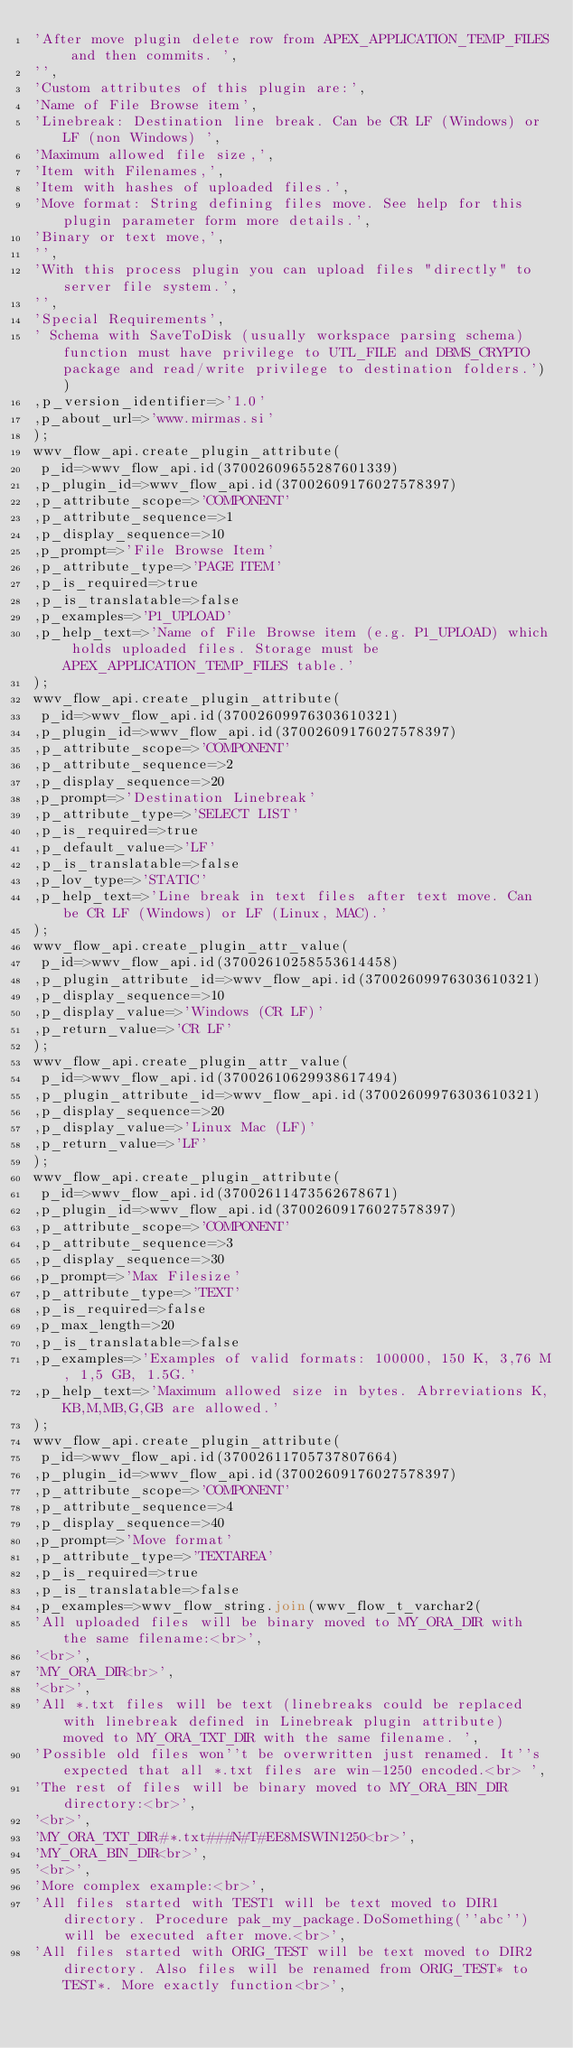Convert code to text. <code><loc_0><loc_0><loc_500><loc_500><_SQL_>'After move plugin delete row from APEX_APPLICATION_TEMP_FILES and then commits. ',
'',
'Custom attributes of this plugin are:',
'Name of File Browse item',
'Linebreak: Destination line break. Can be CR LF (Windows) or LF (non Windows) ',
'Maximum allowed file size,',
'Item with Filenames,',
'Item with hashes of uploaded files.',
'Move format: String defining files move. See help for this plugin parameter form more details.',
'Binary or text move,',
'',
'With this process plugin you can upload files "directly" to server file system.',
'',
'Special Requirements',
' Schema with SaveToDisk (usually workspace parsing schema) function must have privilege to UTL_FILE and DBMS_CRYPTO package and read/write privilege to destination folders.'))
,p_version_identifier=>'1.0'
,p_about_url=>'www.mirmas.si'
);
wwv_flow_api.create_plugin_attribute(
 p_id=>wwv_flow_api.id(37002609655287601339)
,p_plugin_id=>wwv_flow_api.id(37002609176027578397)
,p_attribute_scope=>'COMPONENT'
,p_attribute_sequence=>1
,p_display_sequence=>10
,p_prompt=>'File Browse Item'
,p_attribute_type=>'PAGE ITEM'
,p_is_required=>true
,p_is_translatable=>false
,p_examples=>'P1_UPLOAD'
,p_help_text=>'Name of File Browse item (e.g. P1_UPLOAD) which holds uploaded files. Storage must be APEX_APPLICATION_TEMP_FILES table.'
);
wwv_flow_api.create_plugin_attribute(
 p_id=>wwv_flow_api.id(37002609976303610321)
,p_plugin_id=>wwv_flow_api.id(37002609176027578397)
,p_attribute_scope=>'COMPONENT'
,p_attribute_sequence=>2
,p_display_sequence=>20
,p_prompt=>'Destination Linebreak'
,p_attribute_type=>'SELECT LIST'
,p_is_required=>true
,p_default_value=>'LF'
,p_is_translatable=>false
,p_lov_type=>'STATIC'
,p_help_text=>'Line break in text files after text move. Can be CR LF (Windows) or LF (Linux, MAC).'
);
wwv_flow_api.create_plugin_attr_value(
 p_id=>wwv_flow_api.id(37002610258553614458)
,p_plugin_attribute_id=>wwv_flow_api.id(37002609976303610321)
,p_display_sequence=>10
,p_display_value=>'Windows (CR LF)'
,p_return_value=>'CR LF'
);
wwv_flow_api.create_plugin_attr_value(
 p_id=>wwv_flow_api.id(37002610629938617494)
,p_plugin_attribute_id=>wwv_flow_api.id(37002609976303610321)
,p_display_sequence=>20
,p_display_value=>'Linux Mac (LF)'
,p_return_value=>'LF'
);
wwv_flow_api.create_plugin_attribute(
 p_id=>wwv_flow_api.id(37002611473562678671)
,p_plugin_id=>wwv_flow_api.id(37002609176027578397)
,p_attribute_scope=>'COMPONENT'
,p_attribute_sequence=>3
,p_display_sequence=>30
,p_prompt=>'Max Filesize'
,p_attribute_type=>'TEXT'
,p_is_required=>false
,p_max_length=>20
,p_is_translatable=>false
,p_examples=>'Examples of valid formats: 100000, 150 K, 3,76 M, 1,5 GB, 1.5G.'
,p_help_text=>'Maximum allowed size in bytes. Abrreviations K,KB,M,MB,G,GB are allowed.'
);
wwv_flow_api.create_plugin_attribute(
 p_id=>wwv_flow_api.id(37002611705737807664)
,p_plugin_id=>wwv_flow_api.id(37002609176027578397)
,p_attribute_scope=>'COMPONENT'
,p_attribute_sequence=>4
,p_display_sequence=>40
,p_prompt=>'Move format'
,p_attribute_type=>'TEXTAREA'
,p_is_required=>true
,p_is_translatable=>false
,p_examples=>wwv_flow_string.join(wwv_flow_t_varchar2(
'All uploaded files will be binary moved to MY_ORA_DIR with the same filename:<br>',
'<br>',
'MY_ORA_DIR<br>',
'<br>',
'All *.txt files will be text (linebreaks could be replaced with linebreak defined in Linebreak plugin attribute) moved to MY_ORA_TXT_DIR with the same filename. ',
'Possible old files won''t be overwritten just renamed. It''s expected that all *.txt files are win-1250 encoded.<br> ',
'The rest of files will be binary moved to MY_ORA_BIN_DIR directory:<br>',
'<br>',
'MY_ORA_TXT_DIR#*.txt###N#T#EE8MSWIN1250<br>',
'MY_ORA_BIN_DIR<br>',
'<br>',
'More complex example:<br>',
'All files started with TEST1 will be text moved to DIR1 directory. Procedure pak_my_package.DoSomething(''abc'') will be executed after move.<br>',
'All files started with ORIG_TEST will be text moved to DIR2 directory. Also files will be renamed from ORIG_TEST* to TEST*. More exactly function<br>',</code> 